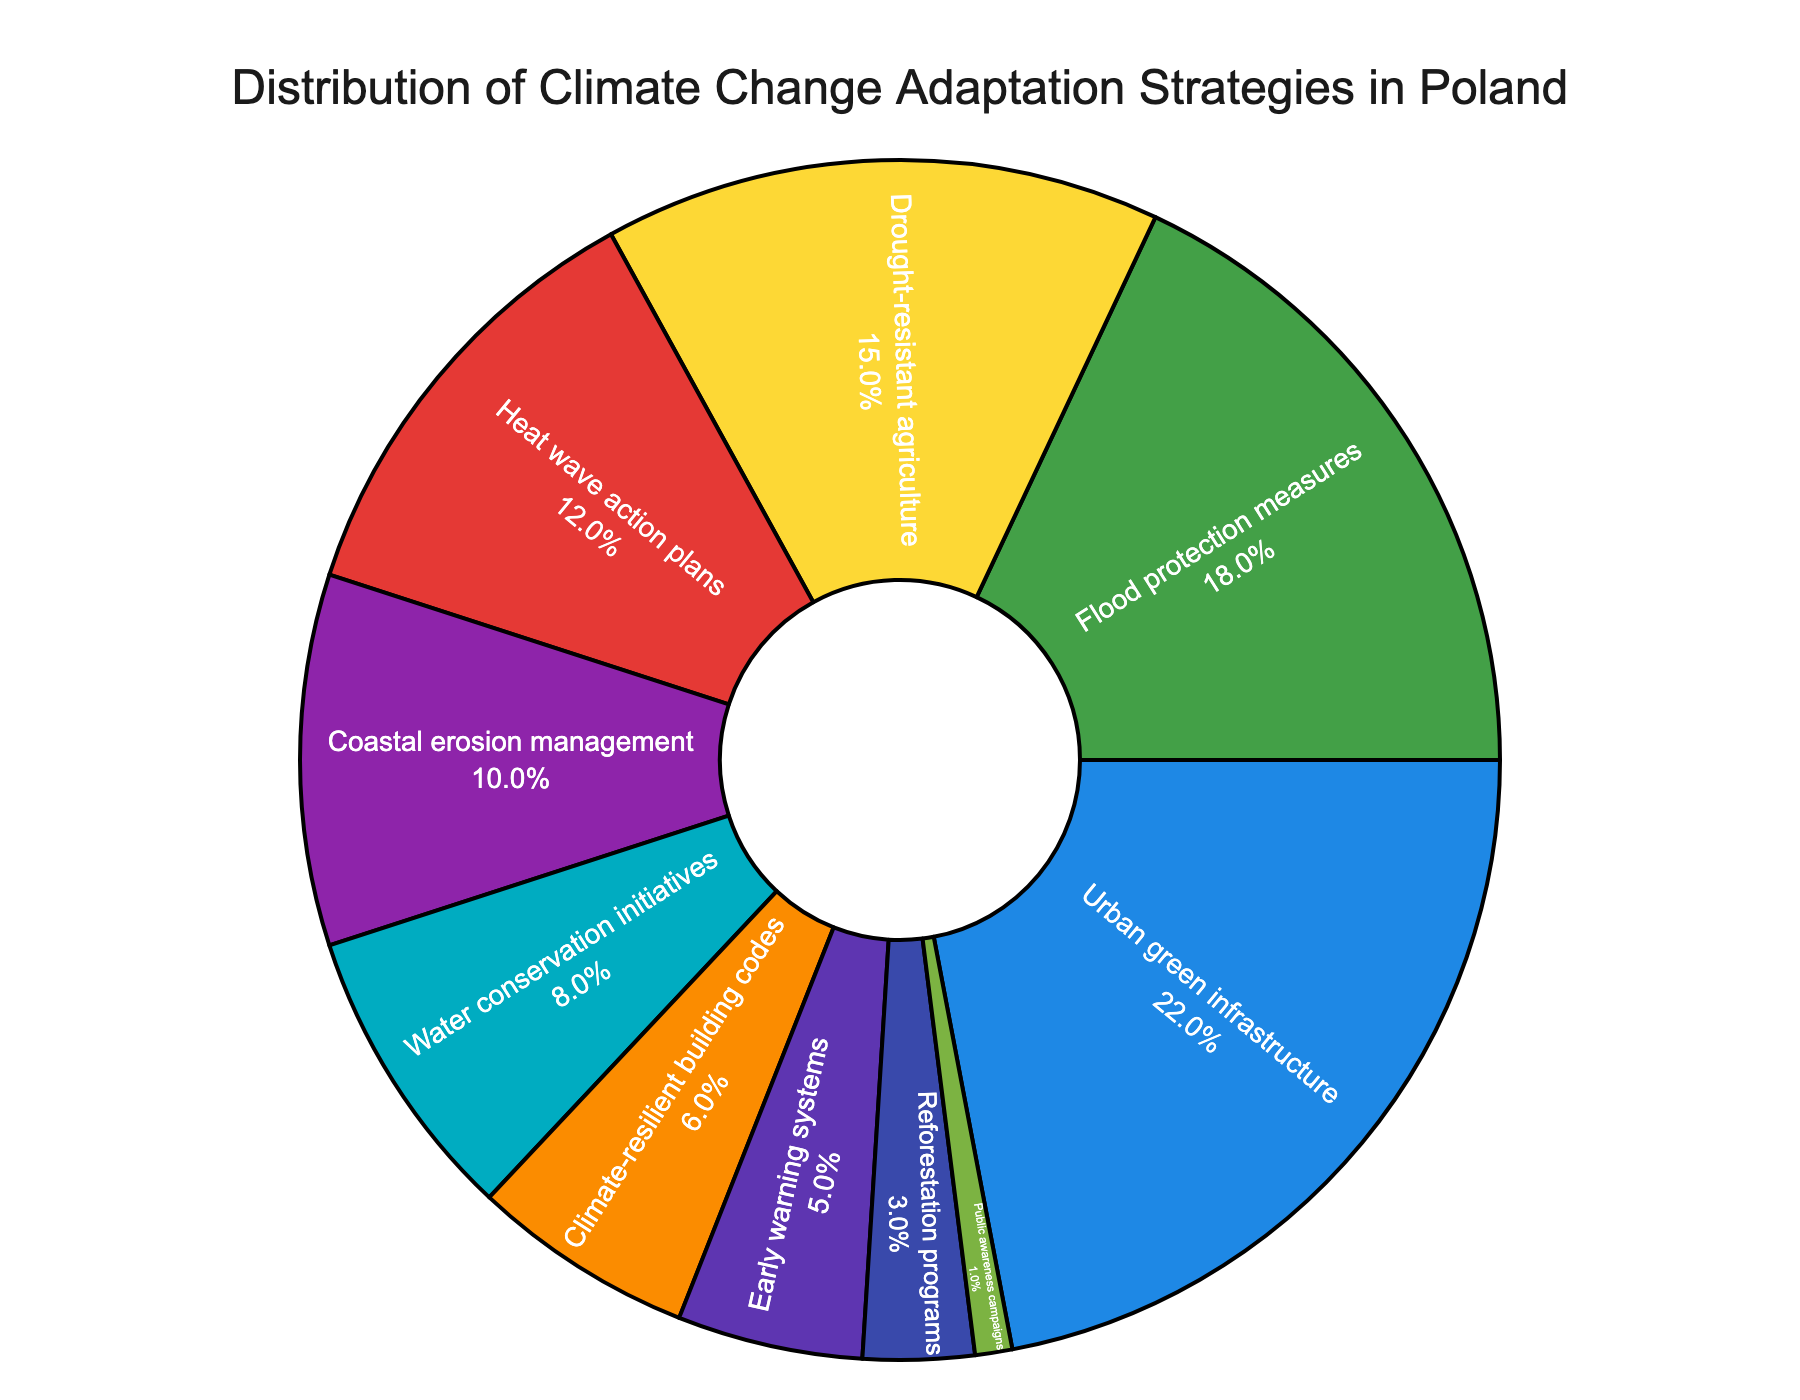What are the top three adaptation strategies used in Poland? First, look at the percentages next to each adaptation strategy. The top three percentages are 22%, 18%, and 15%, which correspond to Urban green infrastructure, Flood protection measures, and Drought-resistant agriculture.
Answer: Urban green infrastructure, Flood protection measures, Drought-resistant agriculture Which adaptation strategy has the lowest percentage in Poland? Identify the smallest percentage in the pie chart. The smallest percentage is 1%, which corresponds to Public awareness campaigns.
Answer: Public awareness campaigns What is the total percentage of strategies related to water (Flood protection measures and Water conservation initiatives)? Find the percentages for Flood protection measures and Water conservation initiatives. Add these percentages: 18% + 8% = 26%.
Answer: 26% How many more percentage points is Urban green infrastructure compared to Early warning systems? Find the percentages for Urban green infrastructure and Early warning systems. Subtract the smaller percentage from the larger one: 22% - 5% = 17%.
Answer: 17% Is the percentage for Heat wave action plans greater than for Coastal erosion management? Compare the percentages for Heat wave action plans (12%) and Coastal erosion management (10%). Since 12% is greater than 10%, the answer is yes.
Answer: Yes What is the difference in percentage between Climate-resilient building codes and Reforestation programs? Find the percentages for Climate-resilient building codes and Reforestation programs. Subtract the smaller percentage from the larger one: 6% - 3% = 3%.
Answer: 3% Name two strategies that together account for less than 10% of the total adaptations. Identify strategies with small percentages. Reforestation programs (3%) and Public awareness campaigns (1%) together account for 4%, which is less than 10%.
Answer: Reforestation programs, Public awareness campaigns What is the combined percentage of strategies addressing heat and drought (Heat wave action plans and Drought-resistant agriculture)? Find the percentages for Heat wave action plans and Drought-resistant agriculture. Add these percentages: 12% + 15% = 27%.
Answer: 27% 